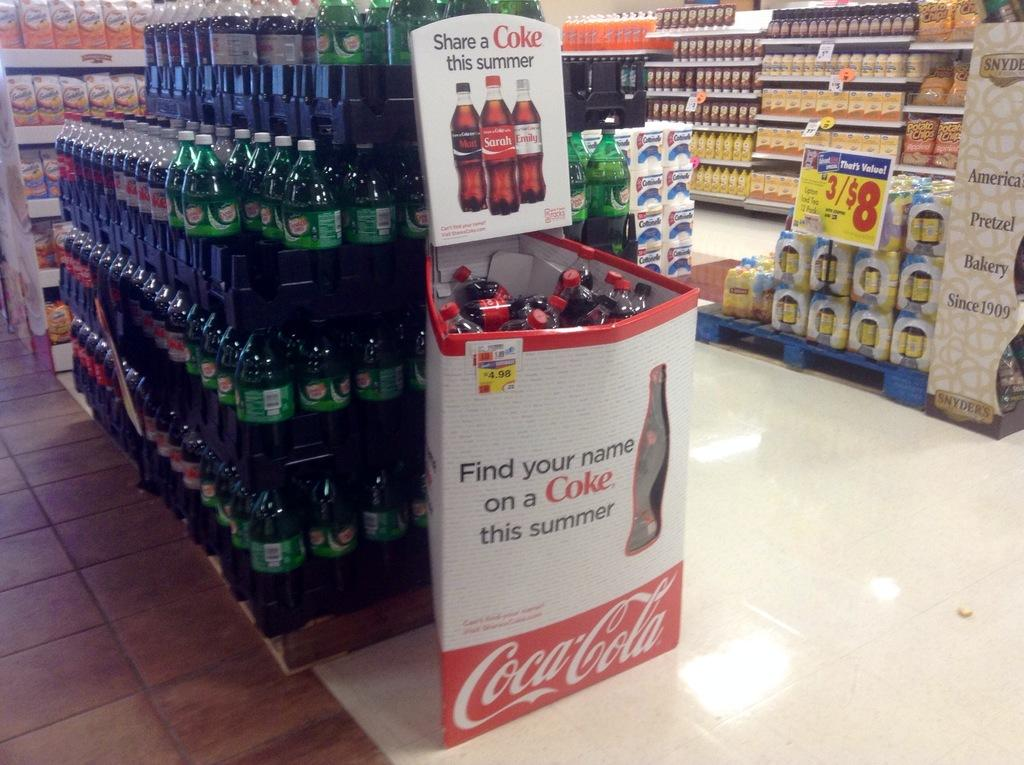<image>
Create a compact narrative representing the image presented. The cardboard box, in front of the bottles of soda, holds bottles of Cokes. 